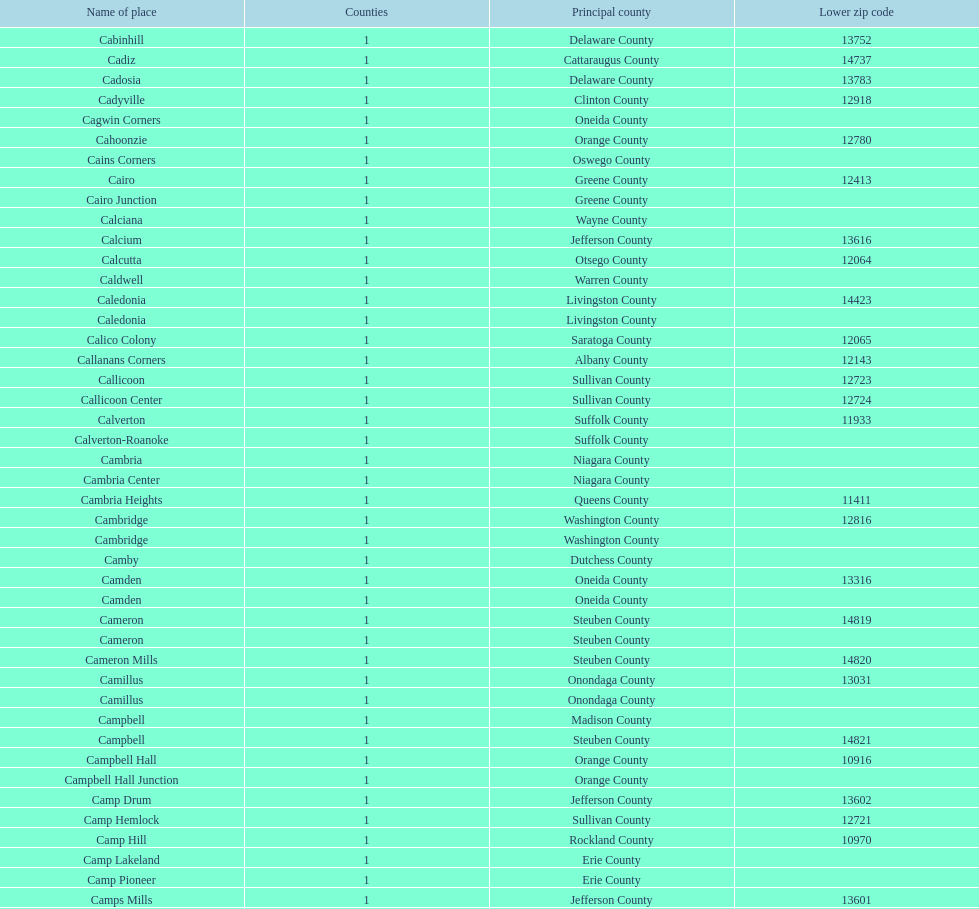What is the total number of locations in greene county? 10. 